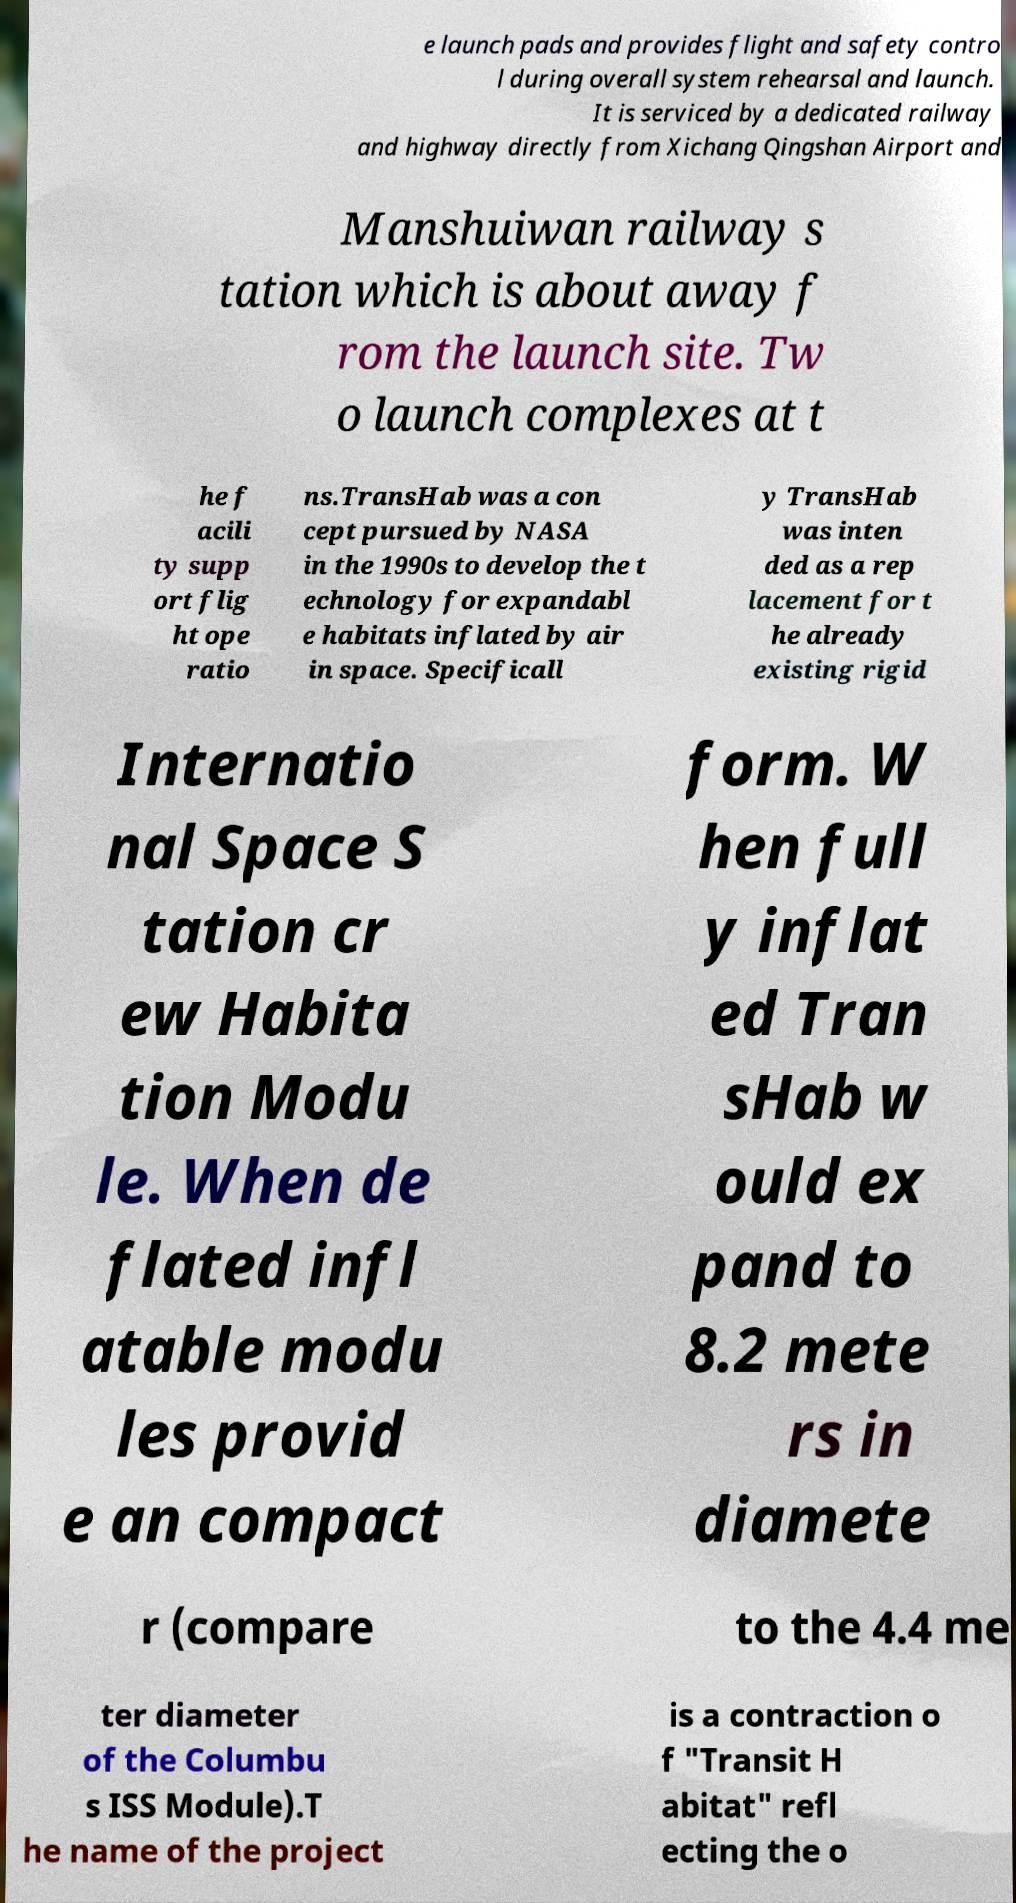Could you extract and type out the text from this image? e launch pads and provides flight and safety contro l during overall system rehearsal and launch. It is serviced by a dedicated railway and highway directly from Xichang Qingshan Airport and Manshuiwan railway s tation which is about away f rom the launch site. Tw o launch complexes at t he f acili ty supp ort flig ht ope ratio ns.TransHab was a con cept pursued by NASA in the 1990s to develop the t echnology for expandabl e habitats inflated by air in space. Specificall y TransHab was inten ded as a rep lacement for t he already existing rigid Internatio nal Space S tation cr ew Habita tion Modu le. When de flated infl atable modu les provid e an compact form. W hen full y inflat ed Tran sHab w ould ex pand to 8.2 mete rs in diamete r (compare to the 4.4 me ter diameter of the Columbu s ISS Module).T he name of the project is a contraction o f "Transit H abitat" refl ecting the o 